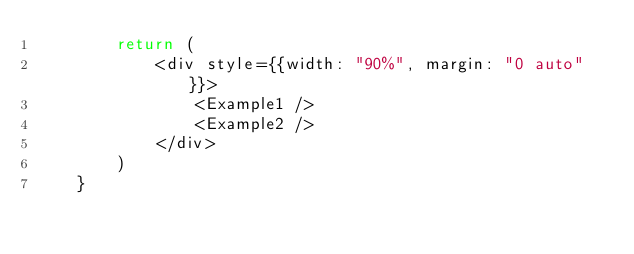Convert code to text. <code><loc_0><loc_0><loc_500><loc_500><_JavaScript_>        return (
            <div style={{width: "90%", margin: "0 auto"}}>
                <Example1 />
                <Example2 />
            </div>
        )
    }


</code> 